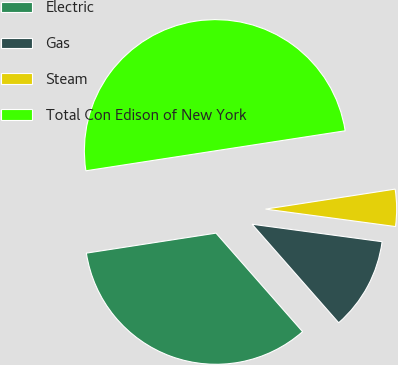<chart> <loc_0><loc_0><loc_500><loc_500><pie_chart><fcel>Electric<fcel>Gas<fcel>Steam<fcel>Total Con Edison of New York<nl><fcel>34.04%<fcel>11.4%<fcel>4.56%<fcel>50.0%<nl></chart> 